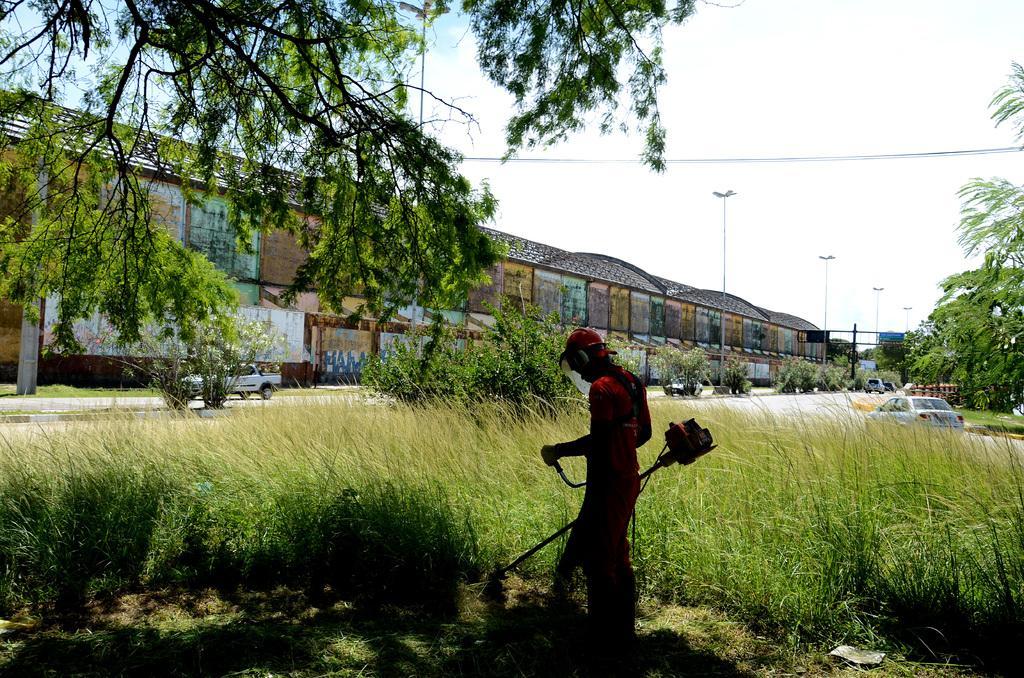How would you summarize this image in a sentence or two? In this image, I can see a person standing and holding an object. There are trees, plants, a building, street lights and vehicles on the road. In the background, there is the sky. 